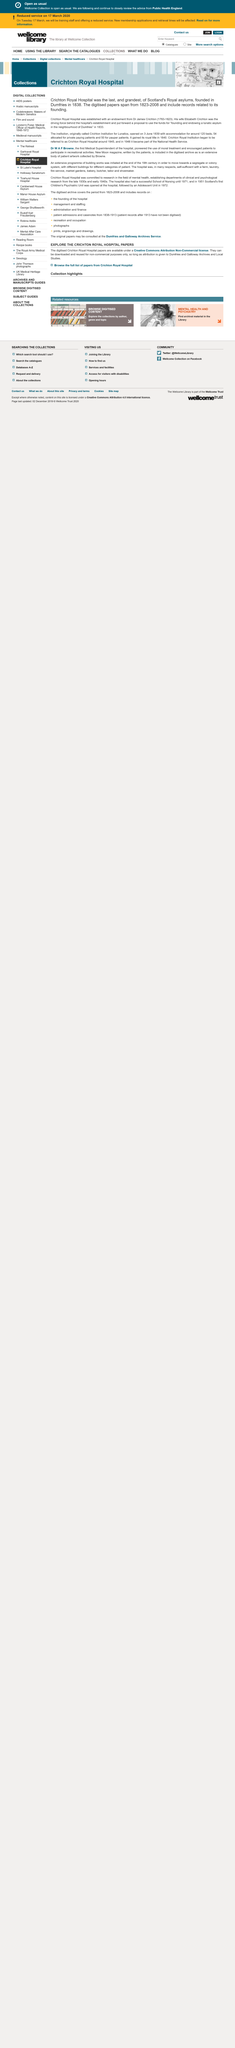Mention a couple of crucial points in this snapshot. There is a person in the image. Crichton appears a total of 8 times. James Crichton was born in 1763. 